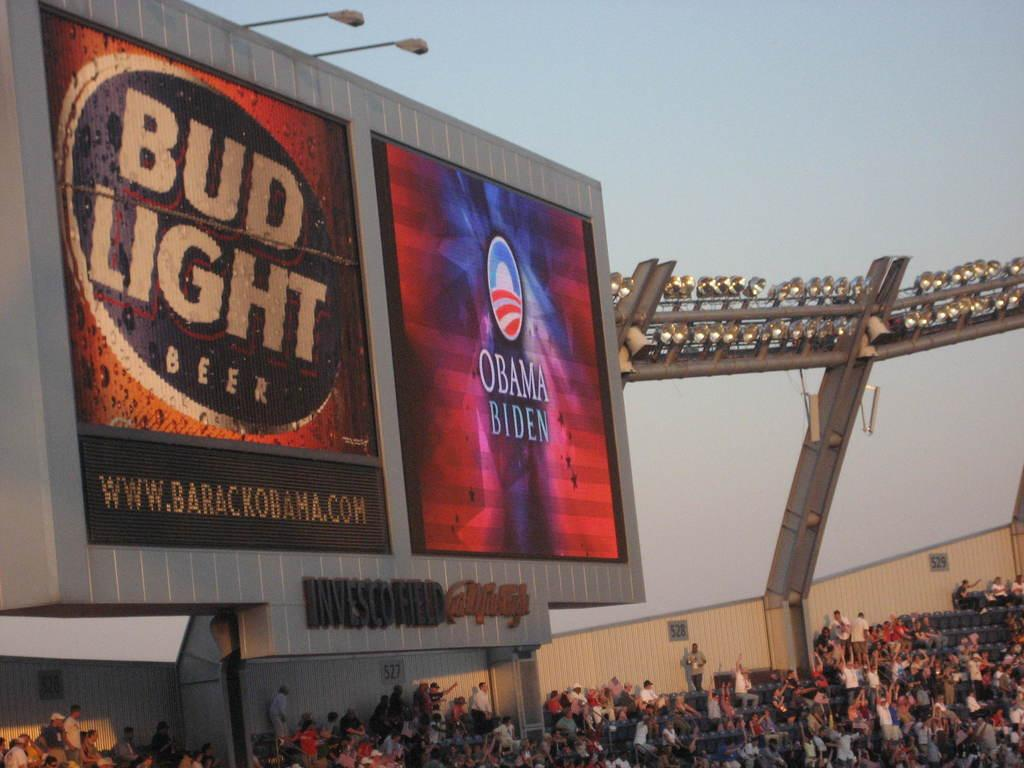<image>
Describe the image concisely. A board advertisement Bud Light and Obama and Biden. 